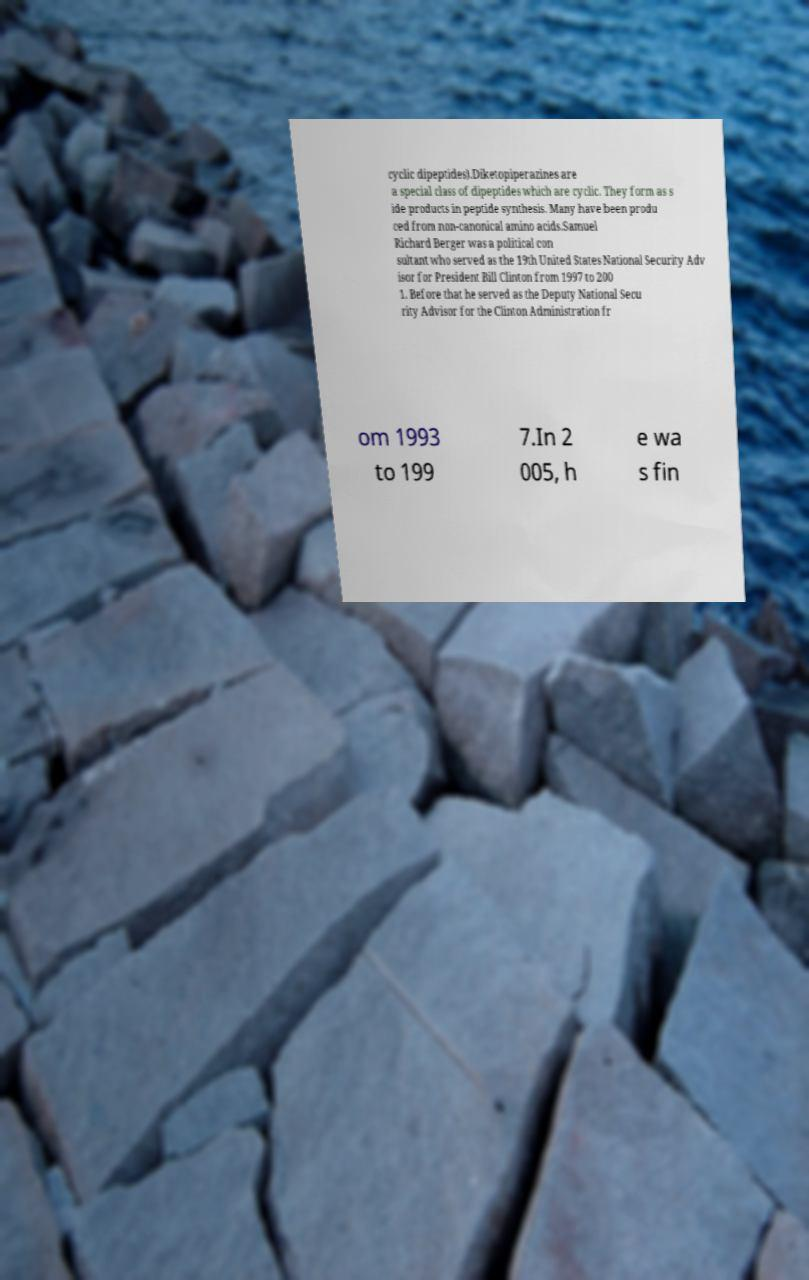Can you accurately transcribe the text from the provided image for me? cyclic dipeptides).Diketopiperazines are a special class of dipeptides which are cyclic. They form as s ide products in peptide synthesis. Many have been produ ced from non-canonical amino acids.Samuel Richard Berger was a political con sultant who served as the 19th United States National Security Adv isor for President Bill Clinton from 1997 to 200 1. Before that he served as the Deputy National Secu rity Advisor for the Clinton Administration fr om 1993 to 199 7.In 2 005, h e wa s fin 